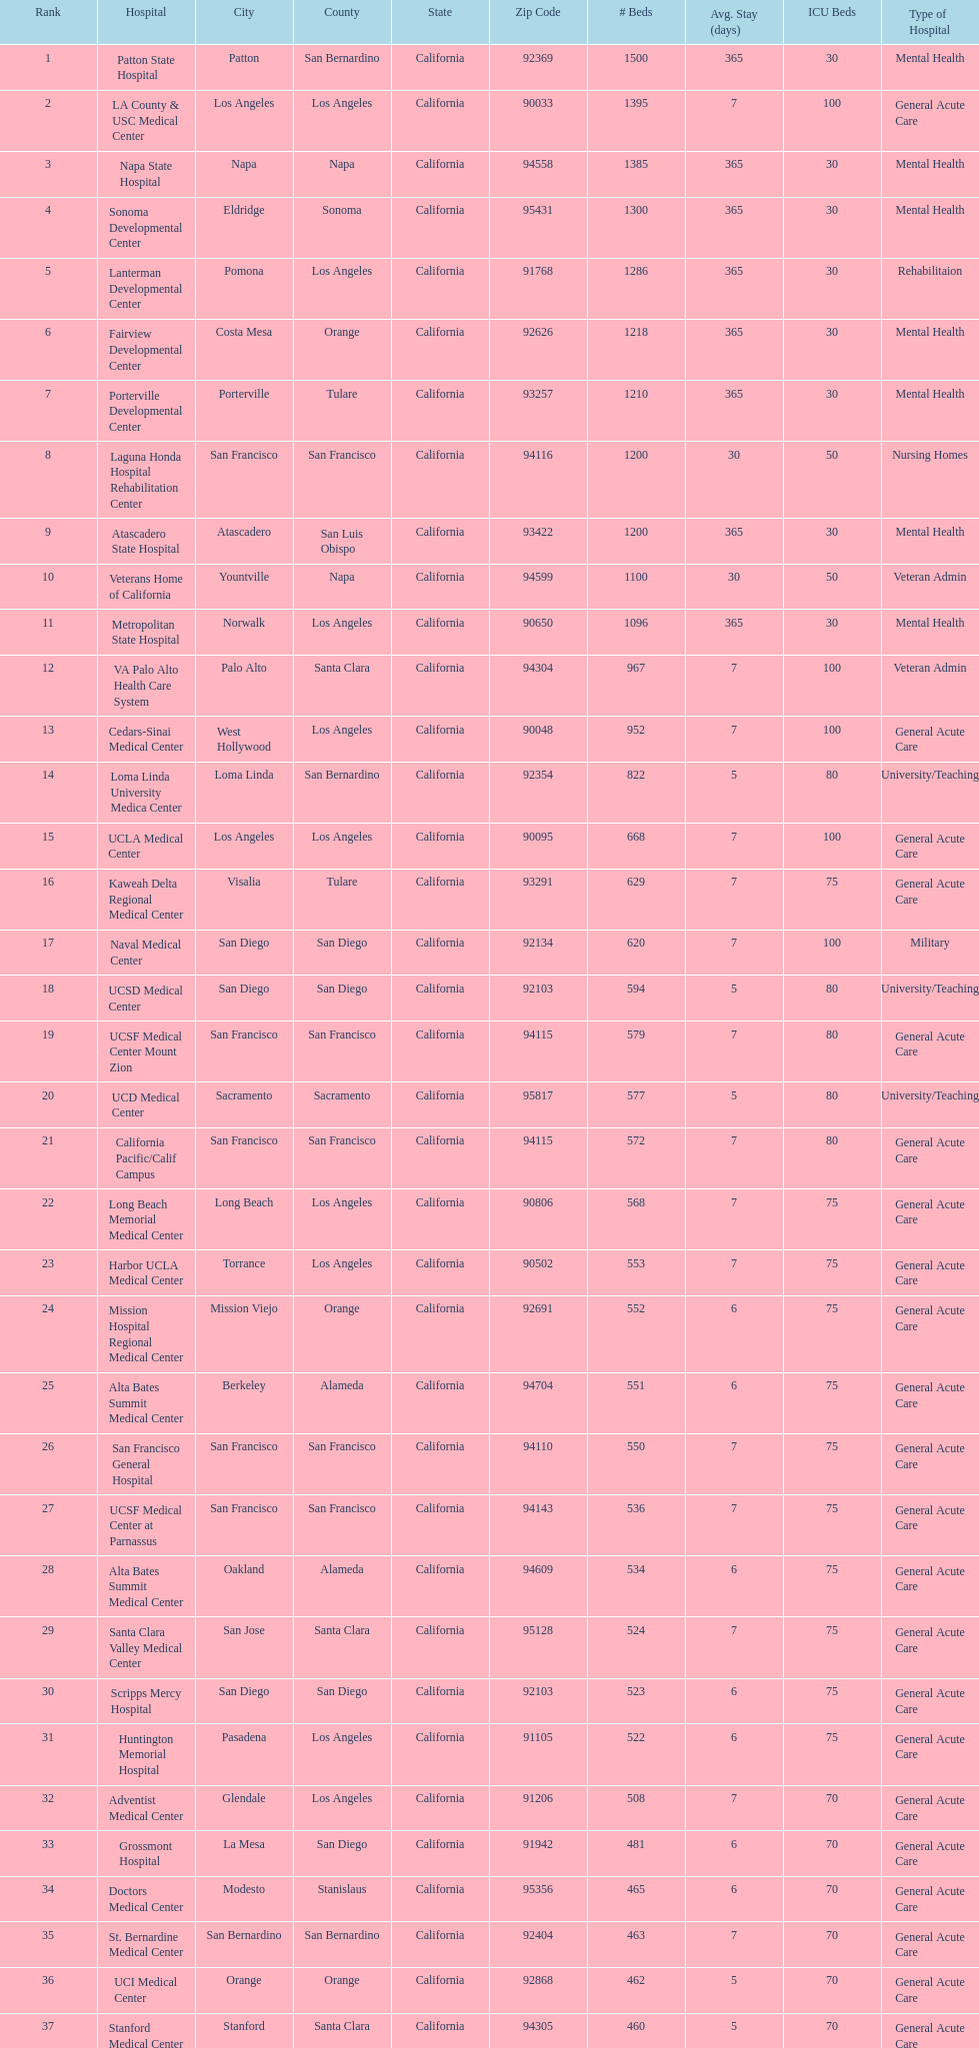How many hospitals have at least 1,000 beds? 11. 